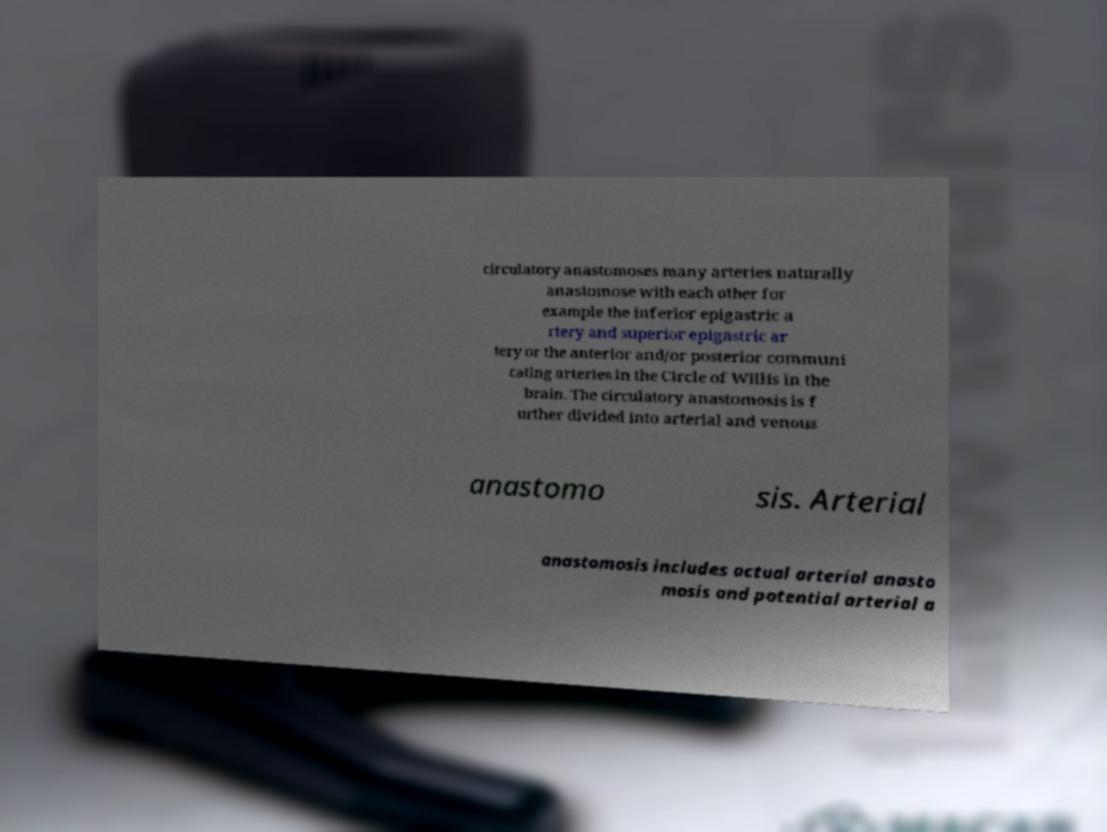For documentation purposes, I need the text within this image transcribed. Could you provide that? circulatory anastomoses many arteries naturally anastomose with each other for example the inferior epigastric a rtery and superior epigastric ar tery or the anterior and/or posterior communi cating arteries in the Circle of Willis in the brain. The circulatory anastomosis is f urther divided into arterial and venous anastomo sis. Arterial anastomosis includes actual arterial anasto mosis and potential arterial a 